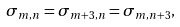Convert formula to latex. <formula><loc_0><loc_0><loc_500><loc_500>\sigma _ { m , n } = \sigma _ { m + 3 , n } = \sigma _ { m , n + 3 } ,</formula> 